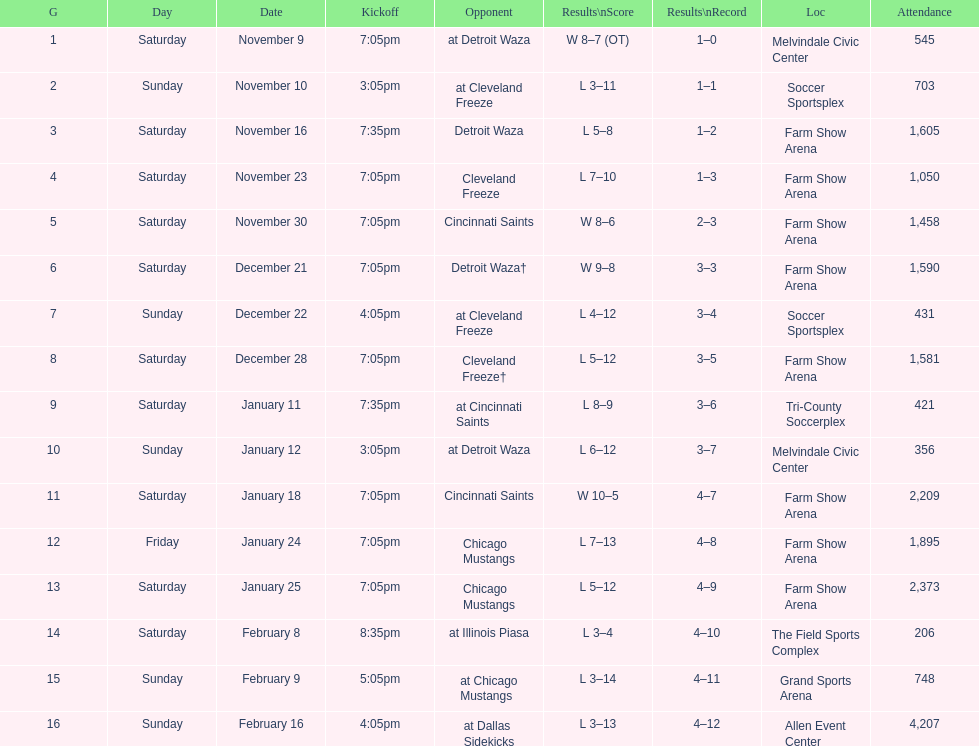How long was the teams longest losing streak? 5 games. 